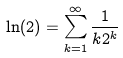<formula> <loc_0><loc_0><loc_500><loc_500>\ln ( 2 ) = \sum _ { k = 1 } ^ { \infty } \frac { 1 } { k 2 ^ { k } }</formula> 